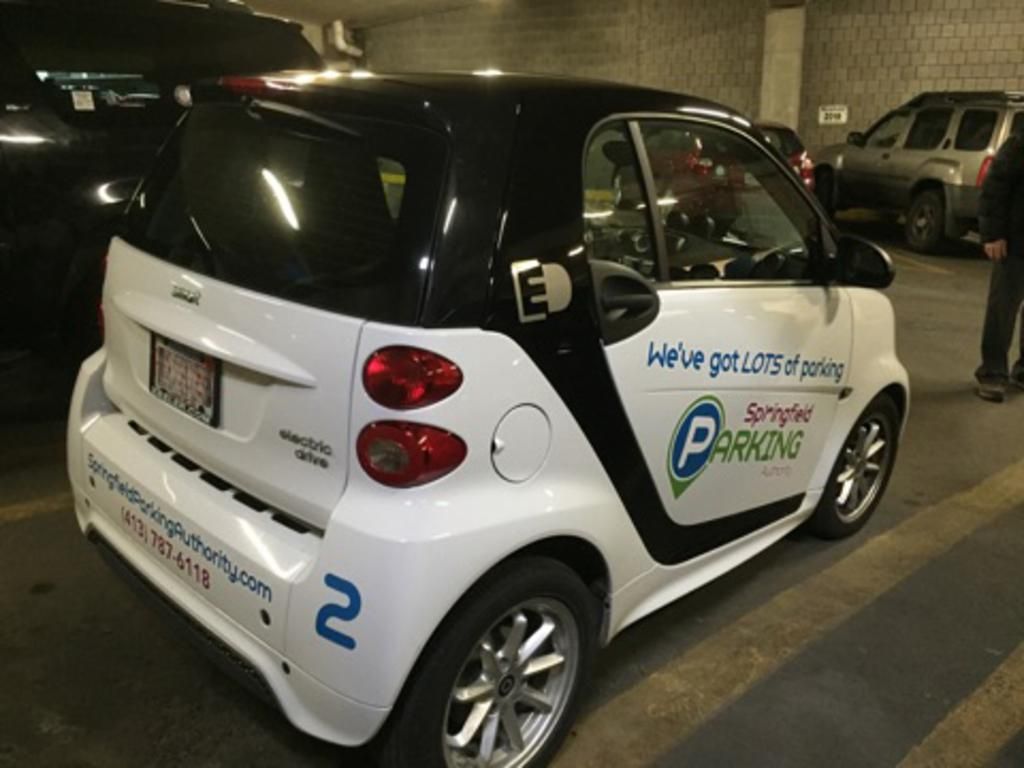What type of vehicle is in the image? There is a white car in the image. Where is the car located? The car is on the ground. What feature can be seen on the car? There is a mirror on the car. How many wheels are visible on the car? There is a wheel on the car. Who is present in the image? There is a person standing near the car. What structures are visible in the background? There is a pillar and a wall in the image. What is the rate of fog in the image? There is no mention of fog in the image, so it is not possible to determine the rate of fog. 